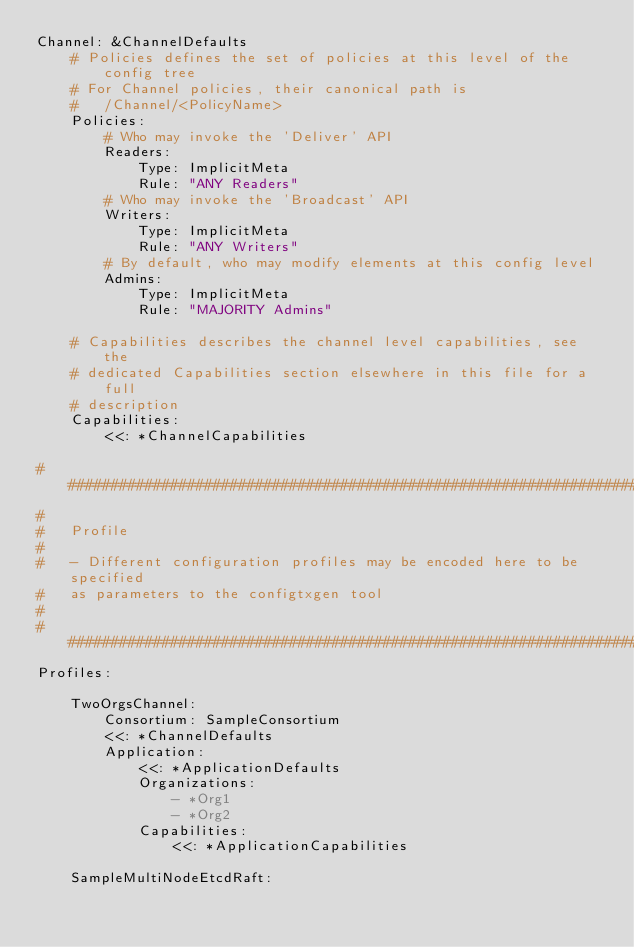Convert code to text. <code><loc_0><loc_0><loc_500><loc_500><_YAML_>Channel: &ChannelDefaults
    # Policies defines the set of policies at this level of the config tree
    # For Channel policies, their canonical path is
    #   /Channel/<PolicyName>
    Policies:
        # Who may invoke the 'Deliver' API
        Readers:
            Type: ImplicitMeta
            Rule: "ANY Readers"
        # Who may invoke the 'Broadcast' API
        Writers:
            Type: ImplicitMeta
            Rule: "ANY Writers"
        # By default, who may modify elements at this config level
        Admins:
            Type: ImplicitMeta
            Rule: "MAJORITY Admins"

    # Capabilities describes the channel level capabilities, see the
    # dedicated Capabilities section elsewhere in this file for a full
    # description
    Capabilities:
        <<: *ChannelCapabilities

################################################################################
#
#   Profile
#
#   - Different configuration profiles may be encoded here to be specified
#   as parameters to the configtxgen tool
#
################################################################################
Profiles:

    TwoOrgsChannel:
        Consortium: SampleConsortium
        <<: *ChannelDefaults
        Application:
            <<: *ApplicationDefaults
            Organizations:
                - *Org1
                - *Org2
            Capabilities:
                <<: *ApplicationCapabilities

    SampleMultiNodeEtcdRaft:</code> 